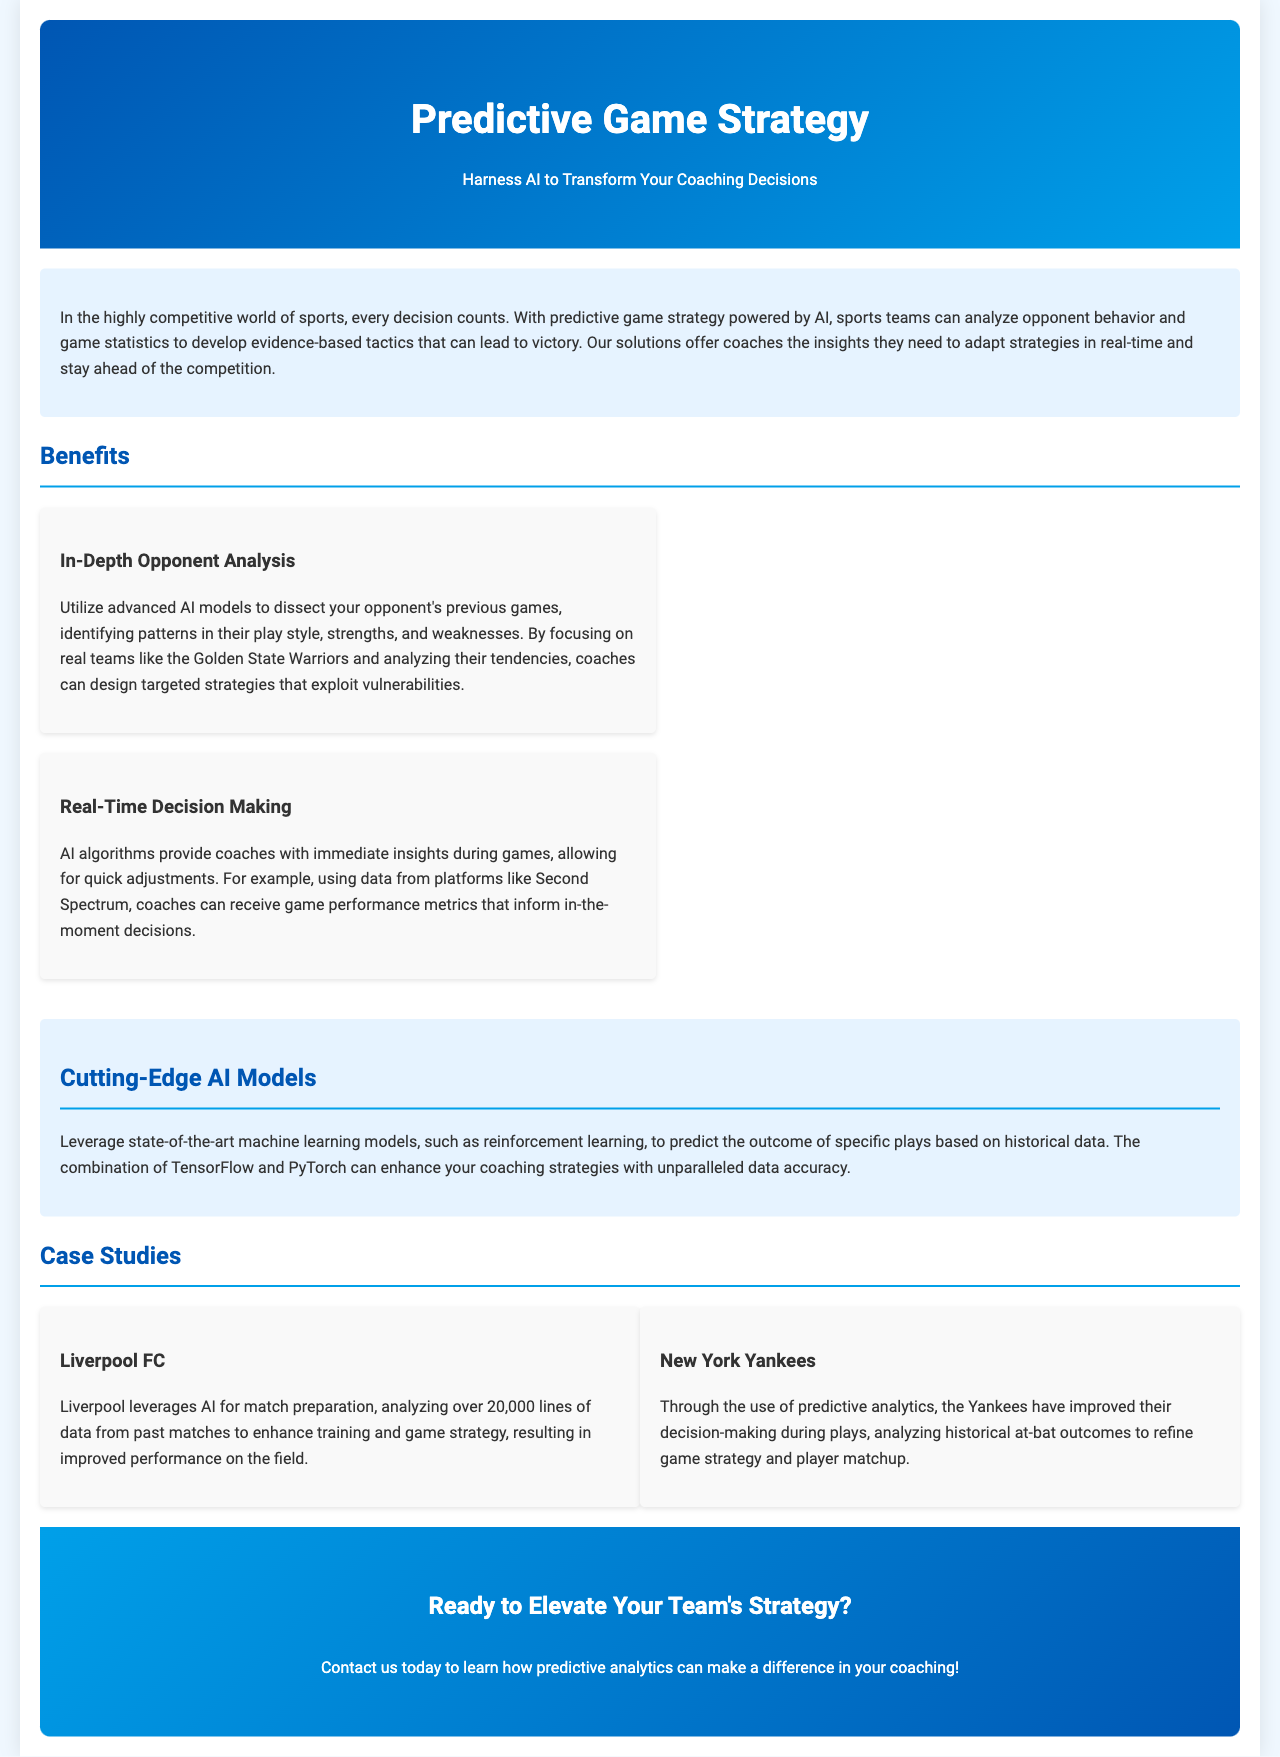what is the title of the document? The title of the document is found in the header section, which is "Predictive Game Strategy."
Answer: Predictive Game Strategy what color is the background of the document? The background color of the document is specified in the style as light blue (#f0f8ff).
Answer: light blue how many case studies are presented in the brochure? The brochure presents two case studies, one on Liverpool FC and one on New York Yankees.
Answer: two what technology is mentioned for leveraging state-of-the-art AI models? The document mentions TensorFlow and PyTorch as technologies for machine learning models.
Answer: TensorFlow and PyTorch what team is used as an example for in-depth opponent analysis? The example used for in-depth opponent analysis is the Golden State Warriors.
Answer: Golden State Warriors what is the core advantage of real-time decision making according to the document? The document states that AI algorithms provide immediate insights during games for quick adjustments.
Answer: immediate insights who is the author of the document? The author is not explicitly mentioned in the document.
Answer: Not specified what is the main outcome Liverpool FC achieved by leveraging AI? Liverpool FC improved their performance on the field by analyzing past match data for training and strategies.
Answer: improved performance what is the call to action at the end of the document? The call to action invites readers to contact for information on how predictive analytics can help coaching strategies.
Answer: Contact us today 